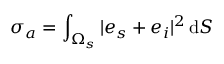Convert formula to latex. <formula><loc_0><loc_0><loc_500><loc_500>\sigma _ { a } = \int _ { \Omega _ { s } } | e _ { s } + e _ { i } | ^ { 2 } \, d S</formula> 